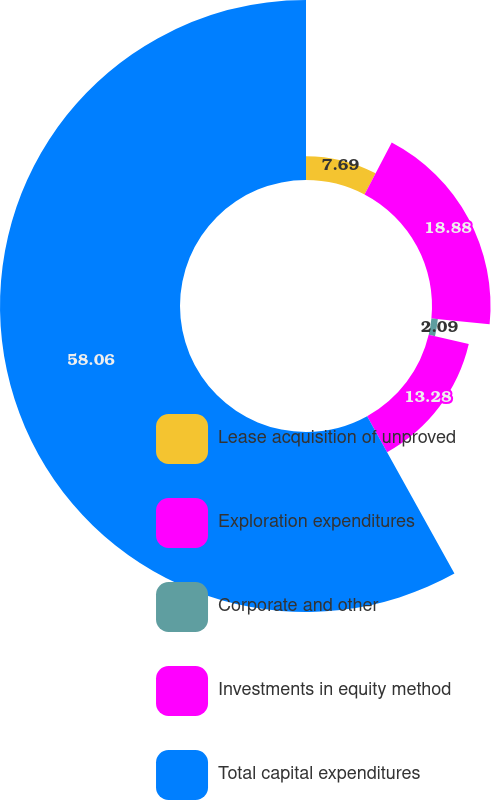Convert chart to OTSL. <chart><loc_0><loc_0><loc_500><loc_500><pie_chart><fcel>Lease acquisition of unproved<fcel>Exploration expenditures<fcel>Corporate and other<fcel>Investments in equity method<fcel>Total capital expenditures<nl><fcel>7.69%<fcel>18.88%<fcel>2.09%<fcel>13.28%<fcel>58.06%<nl></chart> 